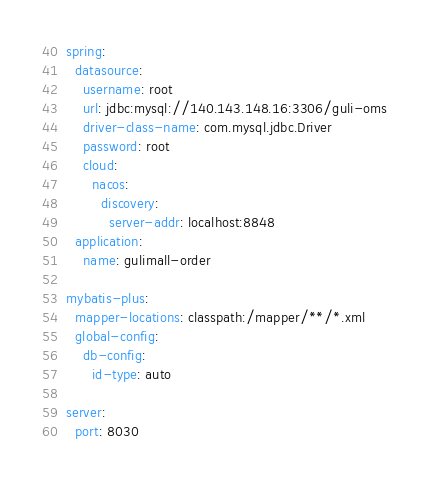Convert code to text. <code><loc_0><loc_0><loc_500><loc_500><_YAML_>spring:
  datasource:
    username: root
    url: jdbc:mysql://140.143.148.16:3306/guli-oms
    driver-class-name: com.mysql.jdbc.Driver
    password: root
    cloud:
      nacos:
        discovery:
          server-addr: localhost:8848
  application:
    name: gulimall-order

mybatis-plus:
  mapper-locations: classpath:/mapper/**/*.xml
  global-config:
    db-config:
      id-type: auto

server:
  port: 8030</code> 